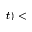Convert formula to latex. <formula><loc_0><loc_0><loc_500><loc_500>t ) <</formula> 